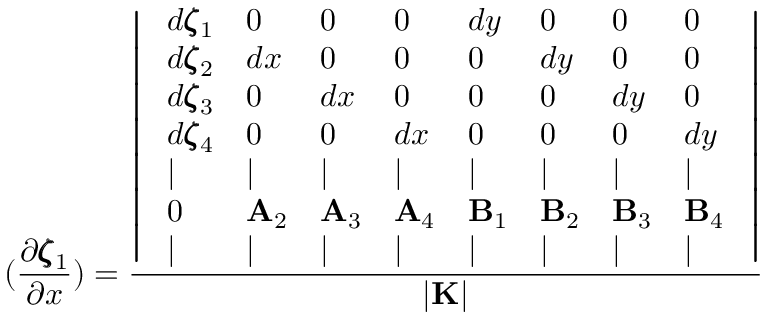Convert formula to latex. <formula><loc_0><loc_0><loc_500><loc_500>( \frac { \partial \pm b { \zeta } _ { 1 } } { \partial x } ) = \frac { \left | \begin{array} { l l l l l l l l } { d \pm b { \zeta } _ { 1 } } & { 0 } & { 0 } & { 0 } & { d y } & { 0 } & { 0 } & { 0 } \\ { d \pm b { \zeta } _ { 2 } } & { d x } & { 0 } & { 0 } & { 0 } & { d y } & { 0 } & { 0 } \\ { d \pm b { \zeta } _ { 3 } } & { 0 } & { d x } & { 0 } & { 0 } & { 0 } & { d y } & { 0 } \\ { d \pm b { \zeta } _ { 4 } } & { 0 } & { 0 } & { d x } & { 0 } & { 0 } & { 0 } & { d y } \\ { | } & { | } & { | } & { | } & { | } & { | } & { | } & { | } \\ { 0 } & { { A } _ { 2 } } & { { A } _ { 3 } } & { { A } _ { 4 } } & { { B } _ { 1 } } & { { B } _ { 2 } } & { { B } _ { 3 } } & { { B } _ { 4 } } \\ { | } & { | } & { | } & { | } & { | } & { | } & { | } & { | } \end{array} \right | } { | { K } | }</formula> 